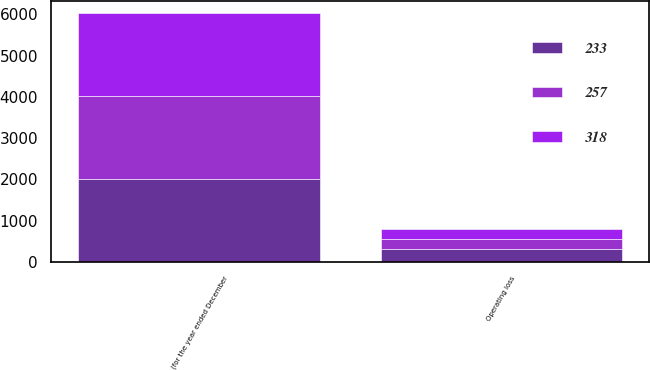Convert chart to OTSL. <chart><loc_0><loc_0><loc_500><loc_500><stacked_bar_chart><ecel><fcel>(for the year ended December<fcel>Operating loss<nl><fcel>233<fcel>2010<fcel>318<nl><fcel>257<fcel>2009<fcel>233<nl><fcel>318<fcel>2008<fcel>257<nl></chart> 